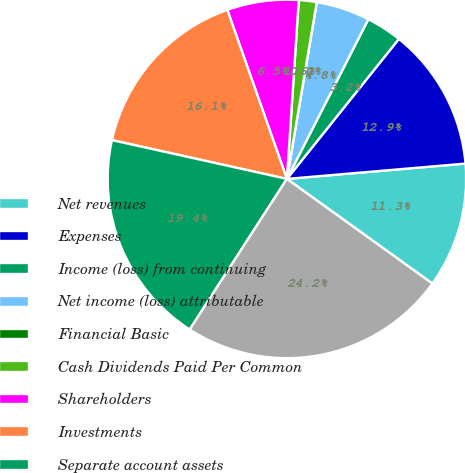Convert chart. <chart><loc_0><loc_0><loc_500><loc_500><pie_chart><fcel>Net revenues<fcel>Expenses<fcel>Income (loss) from continuing<fcel>Net income (loss) attributable<fcel>Financial Basic<fcel>Cash Dividends Paid Per Common<fcel>Shareholders<fcel>Investments<fcel>Separate account assets<fcel>Total assets<nl><fcel>11.29%<fcel>12.9%<fcel>3.23%<fcel>4.84%<fcel>0.0%<fcel>1.61%<fcel>6.45%<fcel>16.13%<fcel>19.35%<fcel>24.19%<nl></chart> 